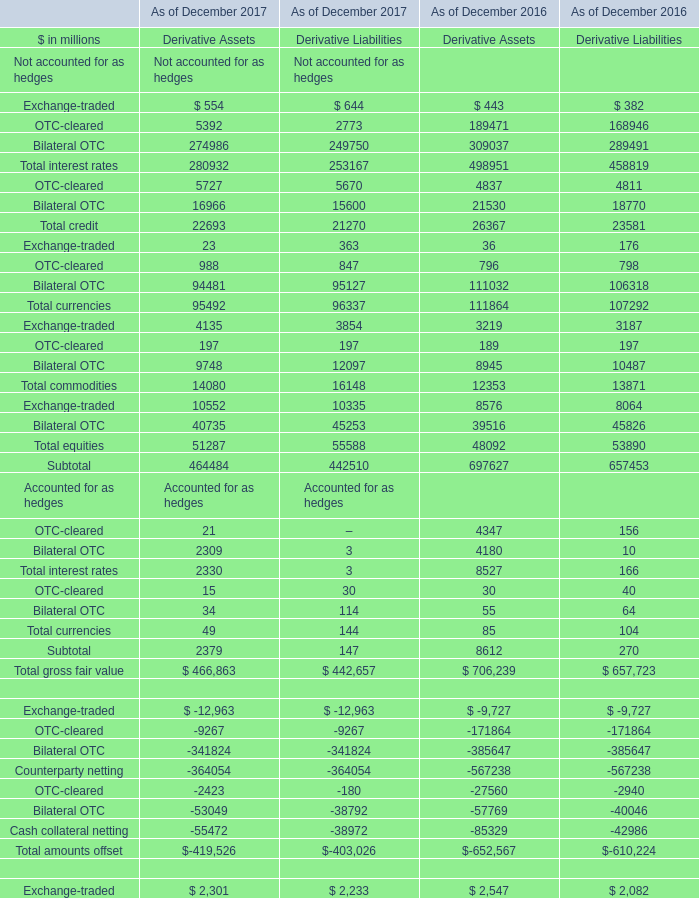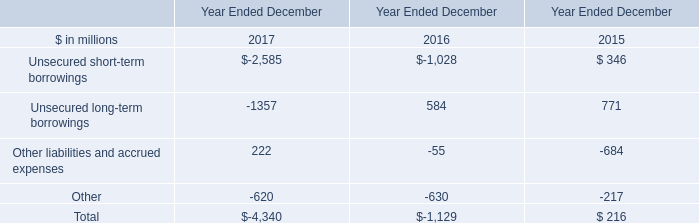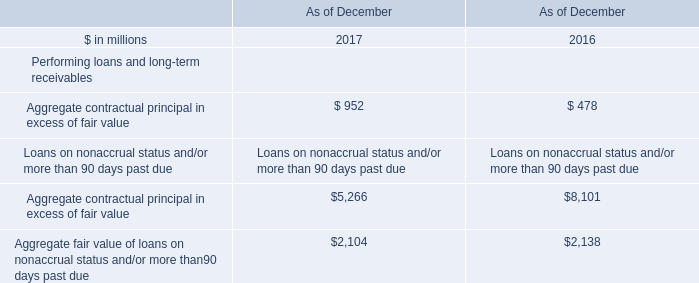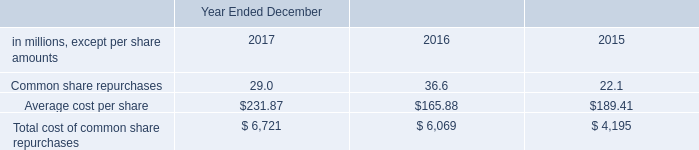Which year is the Derivative Assets for Total interest rates in terms of Accounted for as hedges on December greater than 8000 million? 
Answer: 2016. 